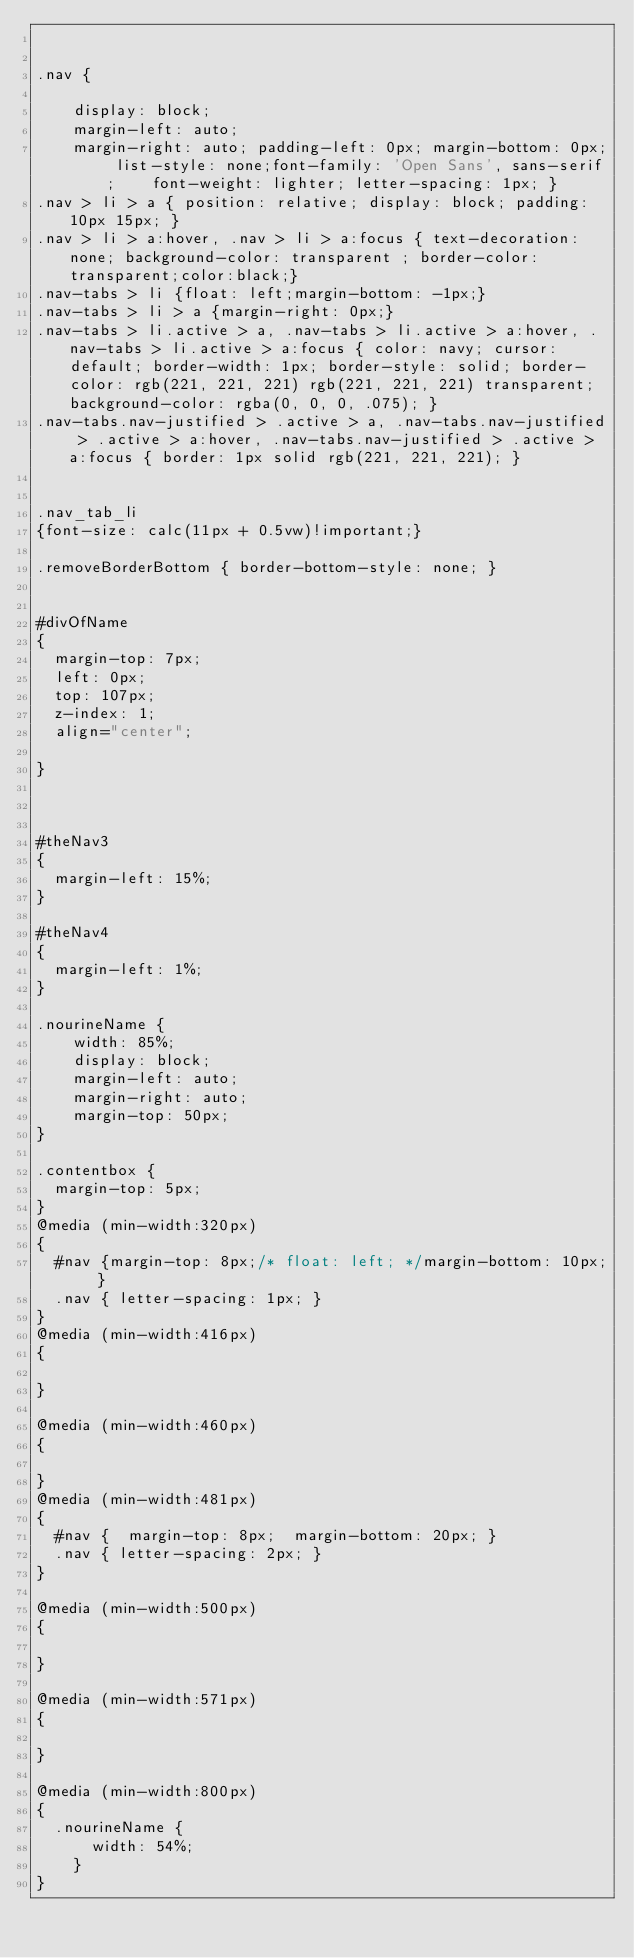Convert code to text. <code><loc_0><loc_0><loc_500><loc_500><_CSS_>

.nav {

    display: block;
    margin-left: auto;
    margin-right: auto; padding-left: 0px; margin-bottom: 0px; list-style: none;font-family: 'Open Sans', sans-serif;    font-weight: lighter; letter-spacing: 1px; }
.nav > li > a { position: relative; display: block; padding: 10px 15px; }
.nav > li > a:hover, .nav > li > a:focus { text-decoration: none; background-color: transparent ; border-color:transparent;color:black;}
.nav-tabs > li {float: left;margin-bottom: -1px;}
.nav-tabs > li > a {margin-right: 0px;}
.nav-tabs > li.active > a, .nav-tabs > li.active > a:hover, .nav-tabs > li.active > a:focus { color: navy; cursor: default; border-width: 1px; border-style: solid; border-color: rgb(221, 221, 221) rgb(221, 221, 221) transparent; background-color: rgba(0, 0, 0, .075); }
.nav-tabs.nav-justified > .active > a, .nav-tabs.nav-justified > .active > a:hover, .nav-tabs.nav-justified > .active > a:focus { border: 1px solid rgb(221, 221, 221); }


.nav_tab_li
{font-size: calc(11px + 0.5vw)!important;}

.removeBorderBottom { border-bottom-style: none; }


#divOfName
{
	margin-top: 7px;
 	left: 0px;
  top: 107px;
  z-index: 1;
  align="center";

}



#theNav3
{
  margin-left: 15%;
}

#theNav4
{
  margin-left: 1%;
}

.nourineName {
    width: 85%;
    display: block;
    margin-left: auto;
    margin-right: auto;
    margin-top: 50px;
}

.contentbox {
  margin-top: 5px;
}
@media (min-width:320px)
{
	#nav {margin-top: 8px;/* float: left; */margin-bottom: 10px; }
  .nav { letter-spacing: 1px; }
}
@media (min-width:416px)
{
 
}

@media (min-width:460px)
{

}
@media (min-width:481px)
{
	#nav {  margin-top: 8px;  margin-bottom: 20px; }
  .nav { letter-spacing: 2px; }
}

@media (min-width:500px)
{

}

@media (min-width:571px)
{

}

@media (min-width:800px)
{
  .nourineName {
      width: 54%;
    }
}
</code> 